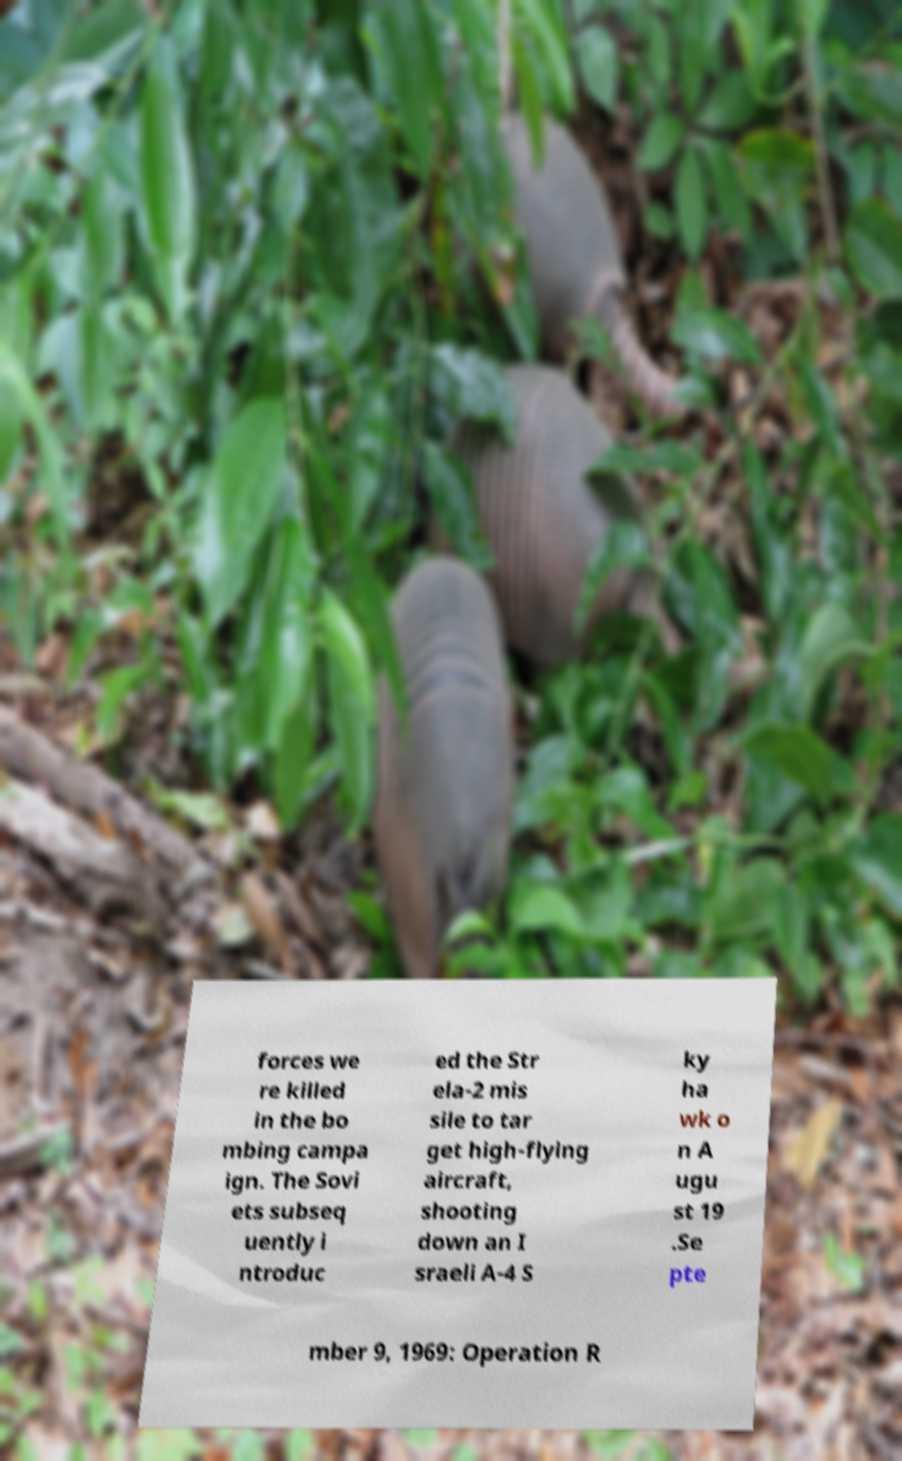Please read and relay the text visible in this image. What does it say? forces we re killed in the bo mbing campa ign. The Sovi ets subseq uently i ntroduc ed the Str ela-2 mis sile to tar get high-flying aircraft, shooting down an I sraeli A-4 S ky ha wk o n A ugu st 19 .Se pte mber 9, 1969: Operation R 